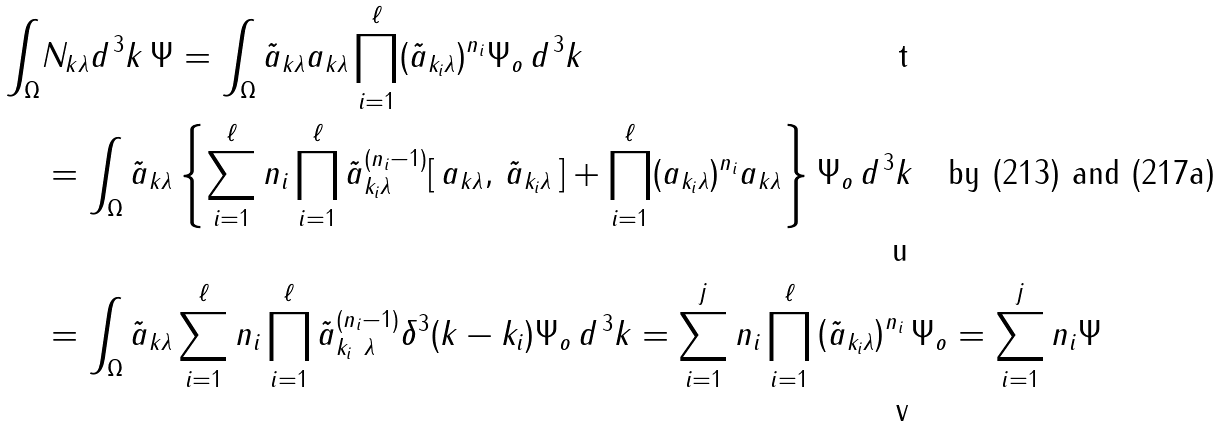Convert formula to latex. <formula><loc_0><loc_0><loc_500><loc_500>\int _ { \Omega } & N _ { k \lambda } d ^ { \, 3 } k \, \Psi = \int _ { \Omega } \tilde { a } _ { k \lambda } a _ { k \lambda } \prod _ { i = 1 } ^ { \ell } ( \tilde { a } _ { k _ { i } \lambda } ) ^ { n _ { i } } \Psi _ { o } \, d ^ { \, 3 } k \\ & = \int _ { \Omega } \tilde { a } _ { k \lambda } \left \{ \sum _ { i = 1 } ^ { \ell } n _ { i } \prod _ { i = 1 } ^ { \ell } \tilde { a } ^ { ( n _ { i } - 1 ) } _ { k _ { i } \lambda } [ \, a _ { k \lambda } , \, \tilde { a } _ { k _ { i } \lambda } \, ] + \prod _ { i = 1 } ^ { \ell } ( a _ { k _ { i } \lambda } ) ^ { n _ { i } } a _ { k \lambda } \right \} \Psi _ { o } \, d ^ { \, 3 } k \quad \text {by (213) and (217a)} \\ & = \int _ { \Omega } \tilde { a } _ { k \lambda } \sum _ { i = 1 } ^ { \ell } n _ { i } \prod _ { i = 1 } ^ { \ell } \tilde { a } ^ { ( n _ { i } - 1 ) } _ { k _ { i } \ \lambda } \delta ^ { 3 } ( k - k _ { i } ) \Psi _ { o } \, d ^ { \, 3 } k = \sum _ { i = 1 } ^ { j } n _ { i } \prod _ { i = 1 } ^ { \ell } \left ( \tilde { a } _ { k _ { i } \lambda } \right ) ^ { n _ { i } } \Psi _ { o } = \sum _ { i = 1 } ^ { j } n _ { i } \Psi</formula> 